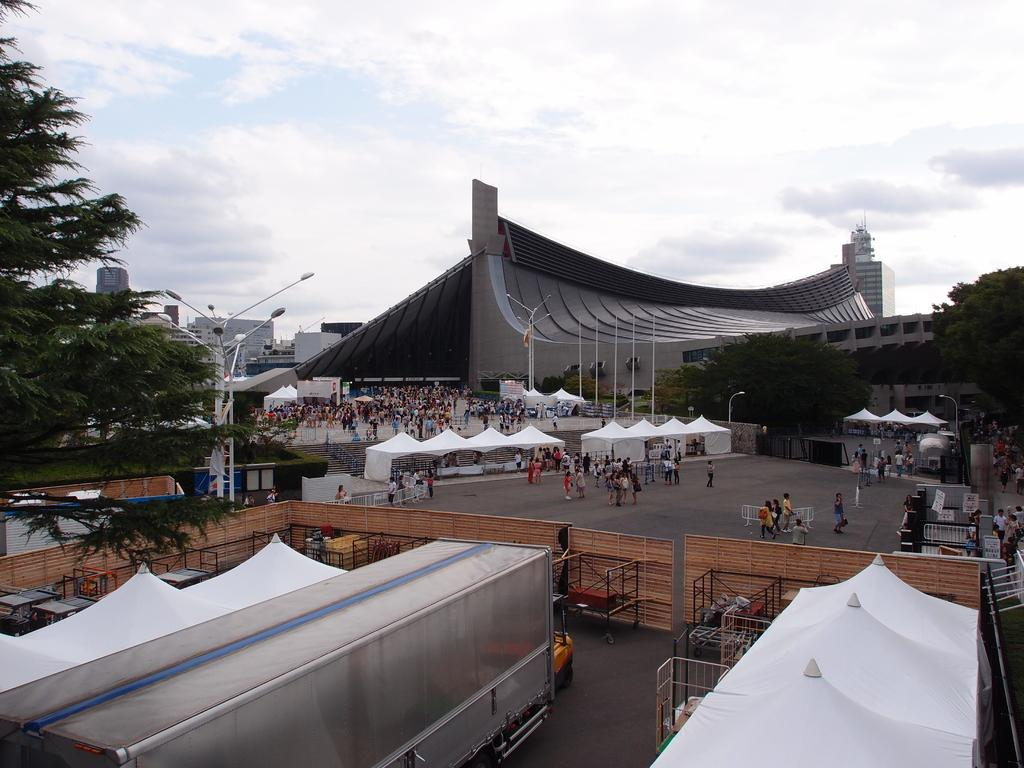What type of temporary shelters can be seen in the image? There are tents in the image. What type of permanent structures are present in the image? There are buildings in the image. What are the people in the image doing? The people in the image are on the road. What are the vertical supports in the image used for? There are poles in the image, which might be used for various purposes such as lighting or signage. What type of vegetation is visible in the image? There are trees in the image. What is visible in the background of the image? The sky is visible in the image. Where are the cats playing with the cake in the image? There are no cats or cake present in the image. What type of tool is being used to hammer in the image? There is no hammer present in the image. 